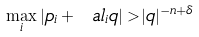Convert formula to latex. <formula><loc_0><loc_0><loc_500><loc_500>\max _ { i } | p _ { i } + \ a l _ { i } q | > | q | ^ { - n + \delta }</formula> 